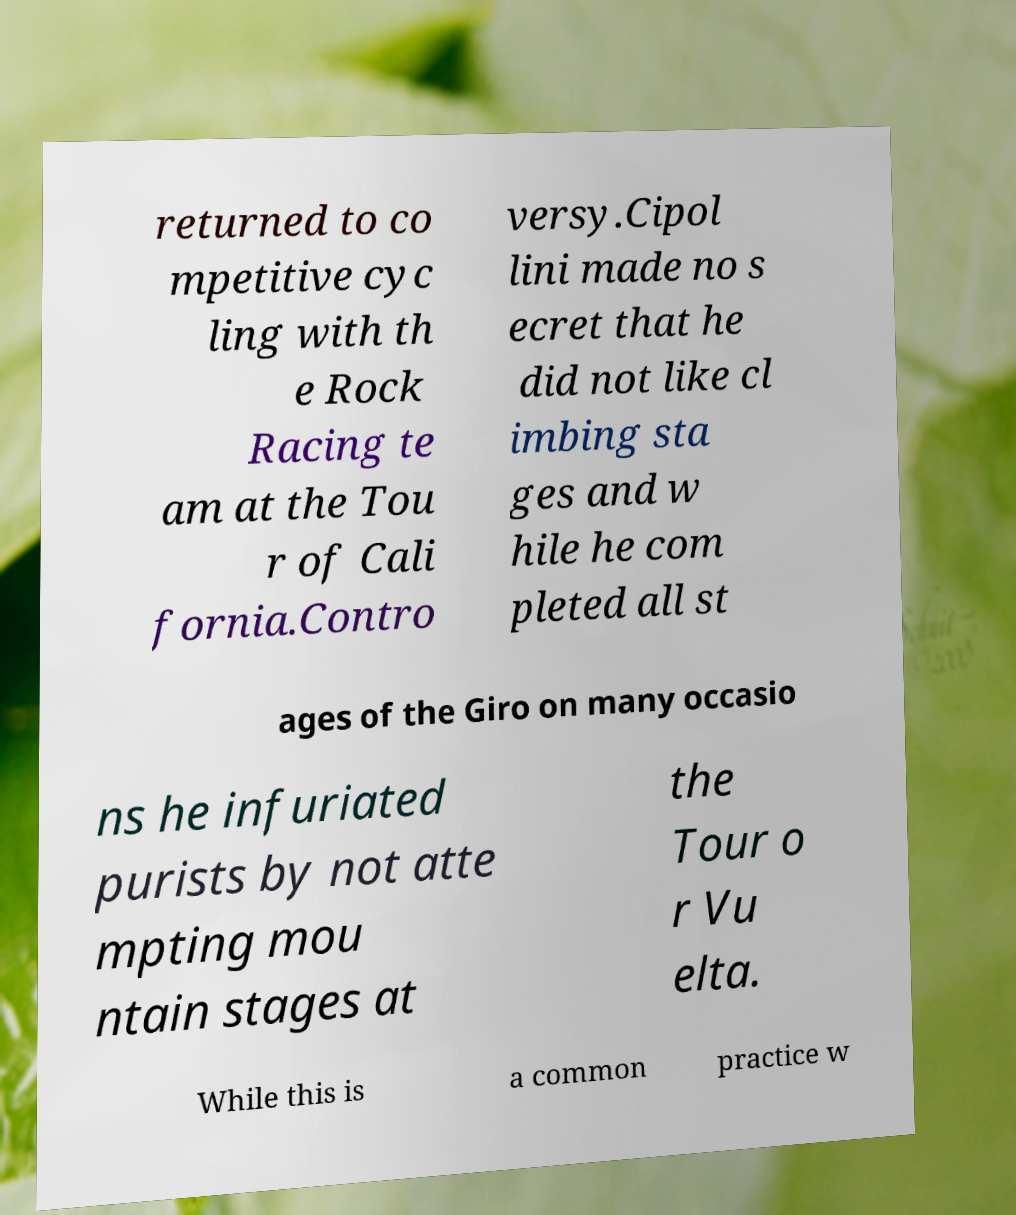Can you read and provide the text displayed in the image?This photo seems to have some interesting text. Can you extract and type it out for me? returned to co mpetitive cyc ling with th e Rock Racing te am at the Tou r of Cali fornia.Contro versy.Cipol lini made no s ecret that he did not like cl imbing sta ges and w hile he com pleted all st ages of the Giro on many occasio ns he infuriated purists by not atte mpting mou ntain stages at the Tour o r Vu elta. While this is a common practice w 